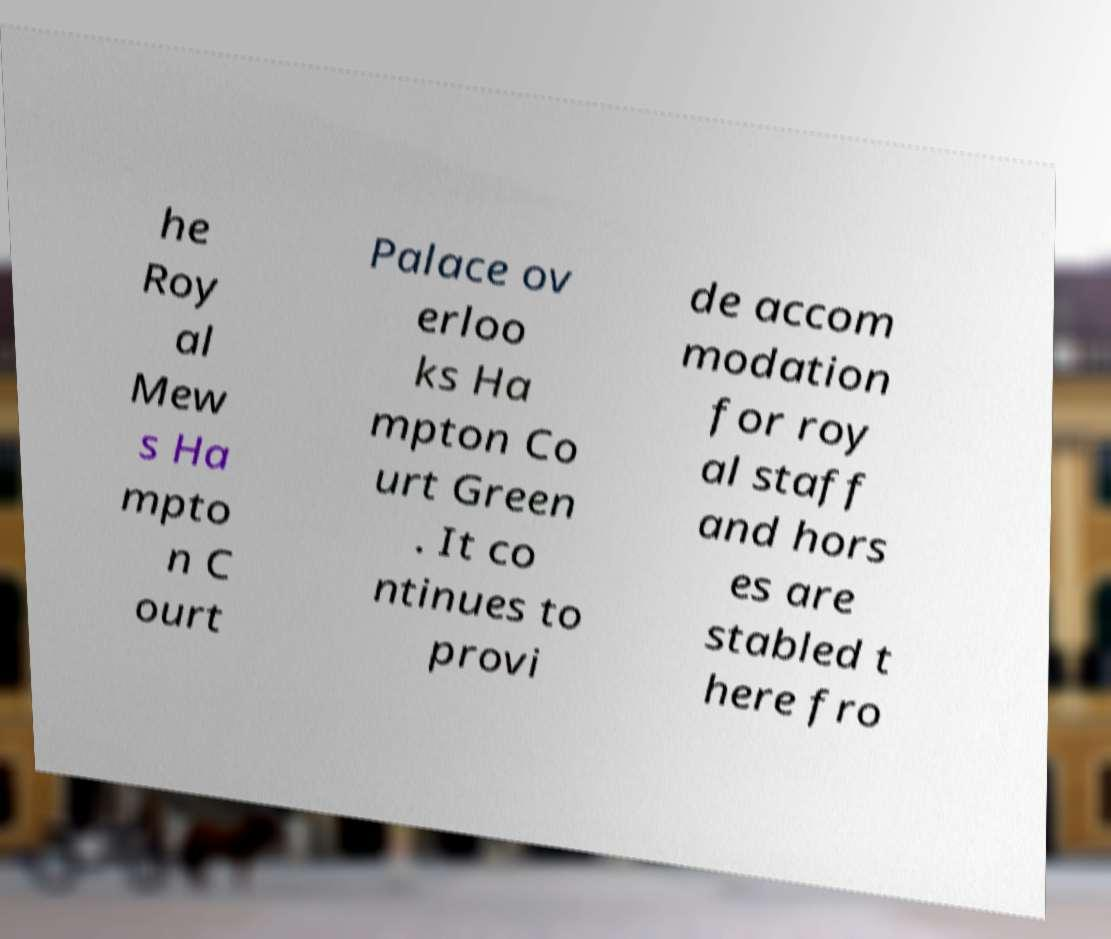Can you accurately transcribe the text from the provided image for me? he Roy al Mew s Ha mpto n C ourt Palace ov erloo ks Ha mpton Co urt Green . It co ntinues to provi de accom modation for roy al staff and hors es are stabled t here fro 